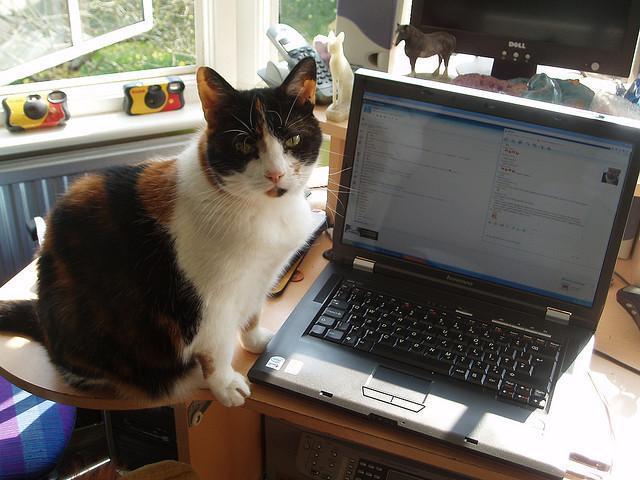How many monitors are in this picture?
Give a very brief answer. 2. How many cats are in this picture?
Give a very brief answer. 1. How many laptops can you see?
Give a very brief answer. 1. 